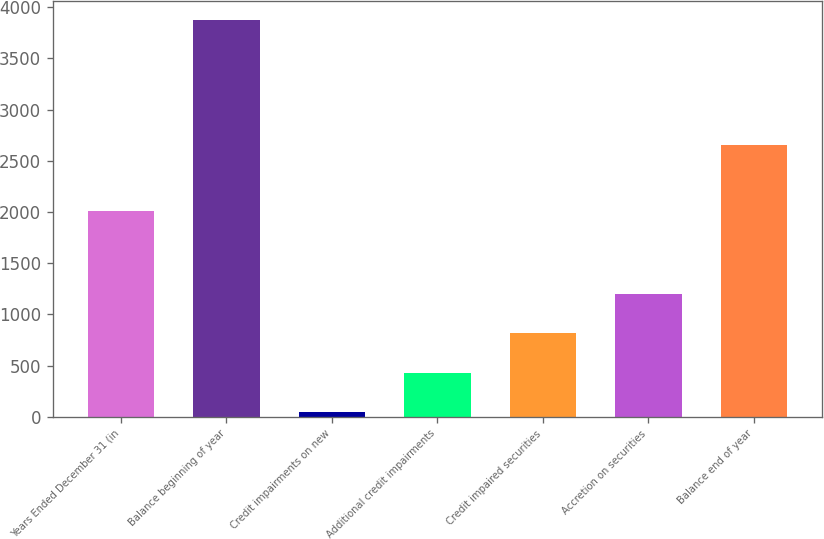Convert chart to OTSL. <chart><loc_0><loc_0><loc_500><loc_500><bar_chart><fcel>Years Ended December 31 (in<fcel>Balance beginning of year<fcel>Credit impairments on new<fcel>Additional credit impairments<fcel>Credit impaired securities<fcel>Accretion on securities<fcel>Balance end of year<nl><fcel>2014<fcel>3872<fcel>49<fcel>431.3<fcel>813.6<fcel>1195.9<fcel>2659<nl></chart> 